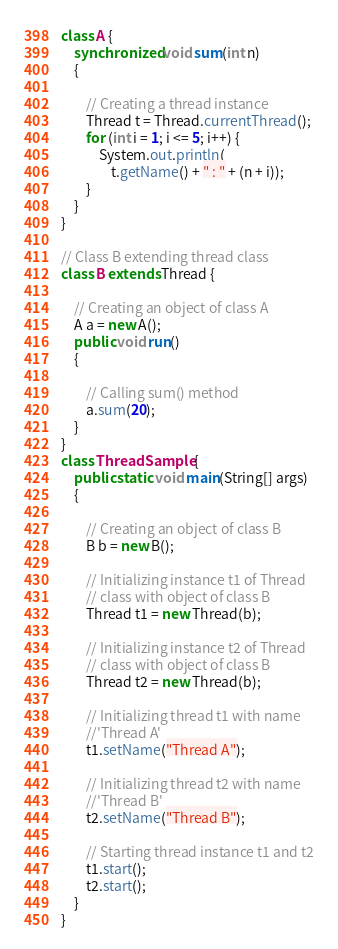<code> <loc_0><loc_0><loc_500><loc_500><_Java_>class A {
	synchronized void sum(int n)
	{

		// Creating a thread instance
		Thread t = Thread.currentThread();
		for (int i = 1; i <= 5; i++) {
			System.out.println(
				t.getName() + " : " + (n + i));
		}
	}
}

// Class B extending thread class
class B extends Thread {

	// Creating an object of class A
	A a = new A();
	public void run()
	{

		// Calling sum() method
		a.sum(20);
	}
}
class ThreadSample {
	public static void main(String[] args)
	{

		// Creating an object of class B
		B b = new B();

		// Initializing instance t1 of Thread
		// class with object of class B
		Thread t1 = new Thread(b);

		// Initializing instance t2 of Thread
		// class with object of class B
		Thread t2 = new Thread(b);

		// Initializing thread t1 with name
		//'Thread A'
		t1.setName("Thread A");

		// Initializing thread t2 with name
		//'Thread B'
		t2.setName("Thread B");

		// Starting thread instance t1 and t2
		t1.start();
		t2.start();
	}
}</code> 